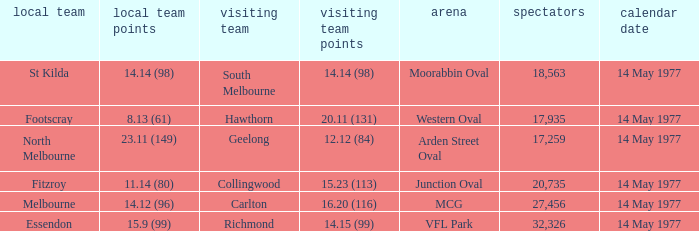How many people were in the crowd with the away team being collingwood? 1.0. 